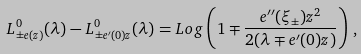<formula> <loc_0><loc_0><loc_500><loc_500>L ^ { 0 } _ { \pm e ( z ) } ( \lambda ) - L ^ { 0 } _ { \pm e ^ { \prime } ( 0 ) z } ( \lambda ) = L o g \left ( 1 \mp \frac { e ^ { \prime \prime } ( \xi _ { \pm } ) z ^ { 2 } } { 2 ( \lambda \mp e ^ { \prime } ( 0 ) z ) } \right ) \, ,</formula> 